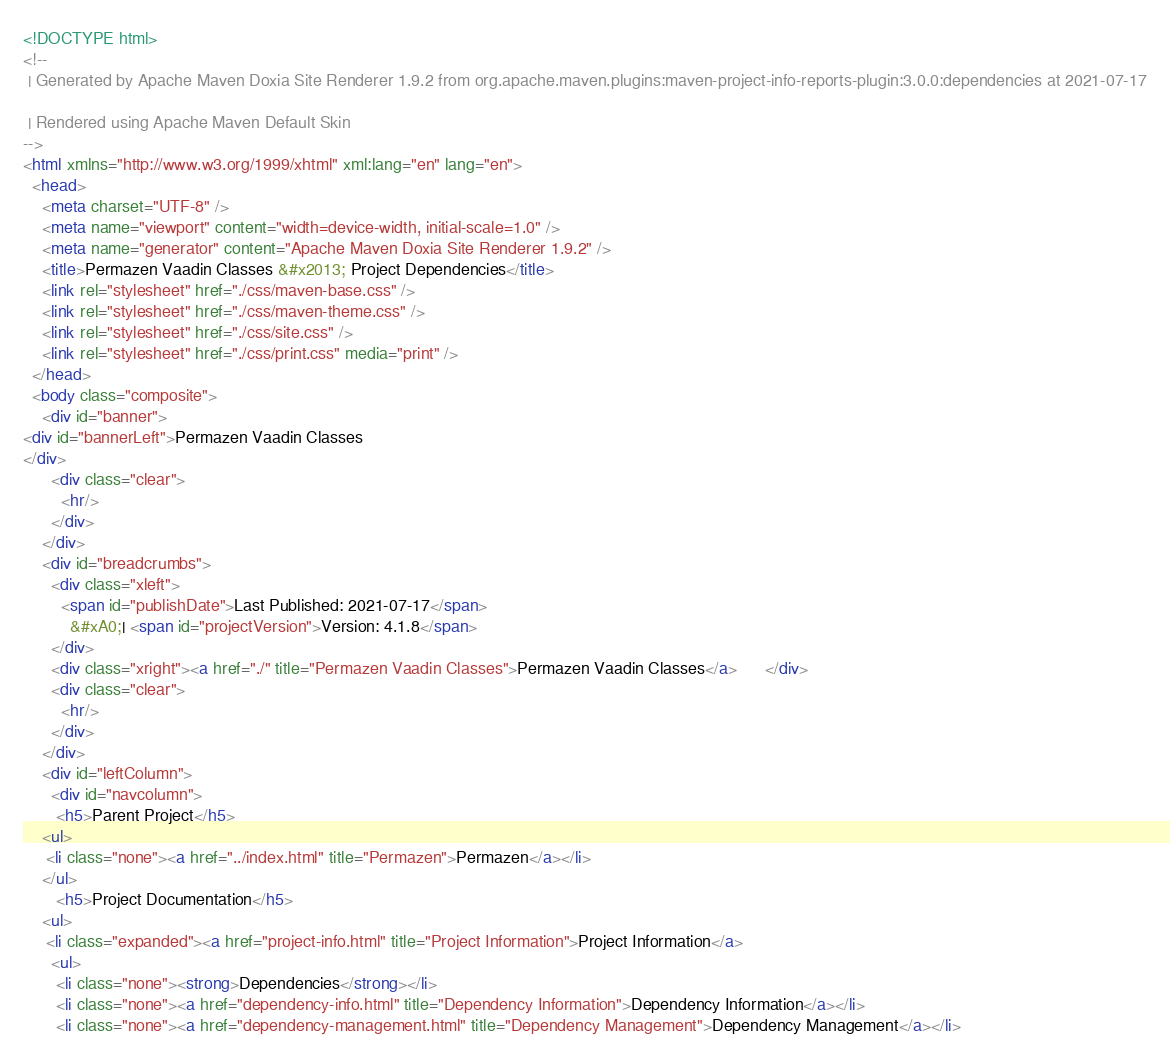<code> <loc_0><loc_0><loc_500><loc_500><_HTML_><!DOCTYPE html>
<!--
 | Generated by Apache Maven Doxia Site Renderer 1.9.2 from org.apache.maven.plugins:maven-project-info-reports-plugin:3.0.0:dependencies at 2021-07-17

 | Rendered using Apache Maven Default Skin
-->
<html xmlns="http://www.w3.org/1999/xhtml" xml:lang="en" lang="en">
  <head>
    <meta charset="UTF-8" />
    <meta name="viewport" content="width=device-width, initial-scale=1.0" />
    <meta name="generator" content="Apache Maven Doxia Site Renderer 1.9.2" />
    <title>Permazen Vaadin Classes &#x2013; Project Dependencies</title>
    <link rel="stylesheet" href="./css/maven-base.css" />
    <link rel="stylesheet" href="./css/maven-theme.css" />
    <link rel="stylesheet" href="./css/site.css" />
    <link rel="stylesheet" href="./css/print.css" media="print" />
  </head>
  <body class="composite">
    <div id="banner">
<div id="bannerLeft">Permazen Vaadin Classes
</div>
      <div class="clear">
        <hr/>
      </div>
    </div>
    <div id="breadcrumbs">
      <div class="xleft">
        <span id="publishDate">Last Published: 2021-07-17</span>
          &#xA0;| <span id="projectVersion">Version: 4.1.8</span>
      </div>
      <div class="xright"><a href="./" title="Permazen Vaadin Classes">Permazen Vaadin Classes</a>      </div>
      <div class="clear">
        <hr/>
      </div>
    </div>
    <div id="leftColumn">
      <div id="navcolumn">
       <h5>Parent Project</h5>
    <ul>
     <li class="none"><a href="../index.html" title="Permazen">Permazen</a></li>
    </ul>
       <h5>Project Documentation</h5>
    <ul>
     <li class="expanded"><a href="project-info.html" title="Project Information">Project Information</a>
      <ul>
       <li class="none"><strong>Dependencies</strong></li>
       <li class="none"><a href="dependency-info.html" title="Dependency Information">Dependency Information</a></li>
       <li class="none"><a href="dependency-management.html" title="Dependency Management">Dependency Management</a></li></code> 